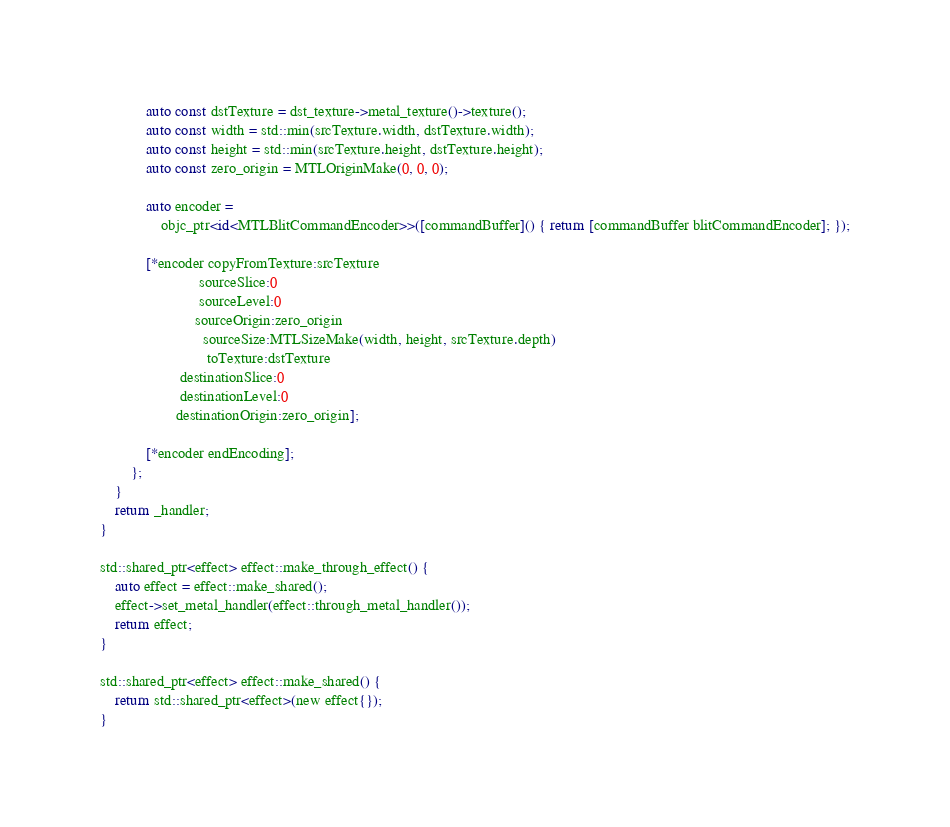Convert code to text. <code><loc_0><loc_0><loc_500><loc_500><_ObjectiveC_>            auto const dstTexture = dst_texture->metal_texture()->texture();
            auto const width = std::min(srcTexture.width, dstTexture.width);
            auto const height = std::min(srcTexture.height, dstTexture.height);
            auto const zero_origin = MTLOriginMake(0, 0, 0);

            auto encoder =
                objc_ptr<id<MTLBlitCommandEncoder>>([commandBuffer]() { return [commandBuffer blitCommandEncoder]; });

            [*encoder copyFromTexture:srcTexture
                          sourceSlice:0
                          sourceLevel:0
                         sourceOrigin:zero_origin
                           sourceSize:MTLSizeMake(width, height, srcTexture.depth)
                            toTexture:dstTexture
                     destinationSlice:0
                     destinationLevel:0
                    destinationOrigin:zero_origin];

            [*encoder endEncoding];
        };
    }
    return _handler;
}

std::shared_ptr<effect> effect::make_through_effect() {
    auto effect = effect::make_shared();
    effect->set_metal_handler(effect::through_metal_handler());
    return effect;
}

std::shared_ptr<effect> effect::make_shared() {
    return std::shared_ptr<effect>(new effect{});
}
</code> 